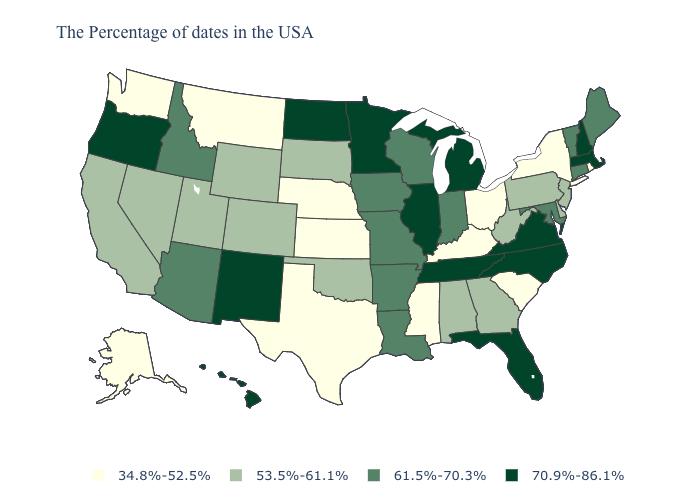What is the value of Nebraska?
Quick response, please. 34.8%-52.5%. What is the value of Mississippi?
Give a very brief answer. 34.8%-52.5%. Which states have the lowest value in the Northeast?
Keep it brief. Rhode Island, New York. Name the states that have a value in the range 61.5%-70.3%?
Give a very brief answer. Maine, Vermont, Connecticut, Maryland, Indiana, Wisconsin, Louisiana, Missouri, Arkansas, Iowa, Arizona, Idaho. Name the states that have a value in the range 70.9%-86.1%?
Keep it brief. Massachusetts, New Hampshire, Virginia, North Carolina, Florida, Michigan, Tennessee, Illinois, Minnesota, North Dakota, New Mexico, Oregon, Hawaii. What is the value of New Jersey?
Write a very short answer. 53.5%-61.1%. What is the value of South Carolina?
Write a very short answer. 34.8%-52.5%. Name the states that have a value in the range 70.9%-86.1%?
Answer briefly. Massachusetts, New Hampshire, Virginia, North Carolina, Florida, Michigan, Tennessee, Illinois, Minnesota, North Dakota, New Mexico, Oregon, Hawaii. Is the legend a continuous bar?
Answer briefly. No. Name the states that have a value in the range 34.8%-52.5%?
Quick response, please. Rhode Island, New York, South Carolina, Ohio, Kentucky, Mississippi, Kansas, Nebraska, Texas, Montana, Washington, Alaska. What is the highest value in the USA?
Answer briefly. 70.9%-86.1%. What is the value of Vermont?
Give a very brief answer. 61.5%-70.3%. Which states have the lowest value in the USA?
Give a very brief answer. Rhode Island, New York, South Carolina, Ohio, Kentucky, Mississippi, Kansas, Nebraska, Texas, Montana, Washington, Alaska. Name the states that have a value in the range 34.8%-52.5%?
Quick response, please. Rhode Island, New York, South Carolina, Ohio, Kentucky, Mississippi, Kansas, Nebraska, Texas, Montana, Washington, Alaska. What is the highest value in the MidWest ?
Quick response, please. 70.9%-86.1%. 